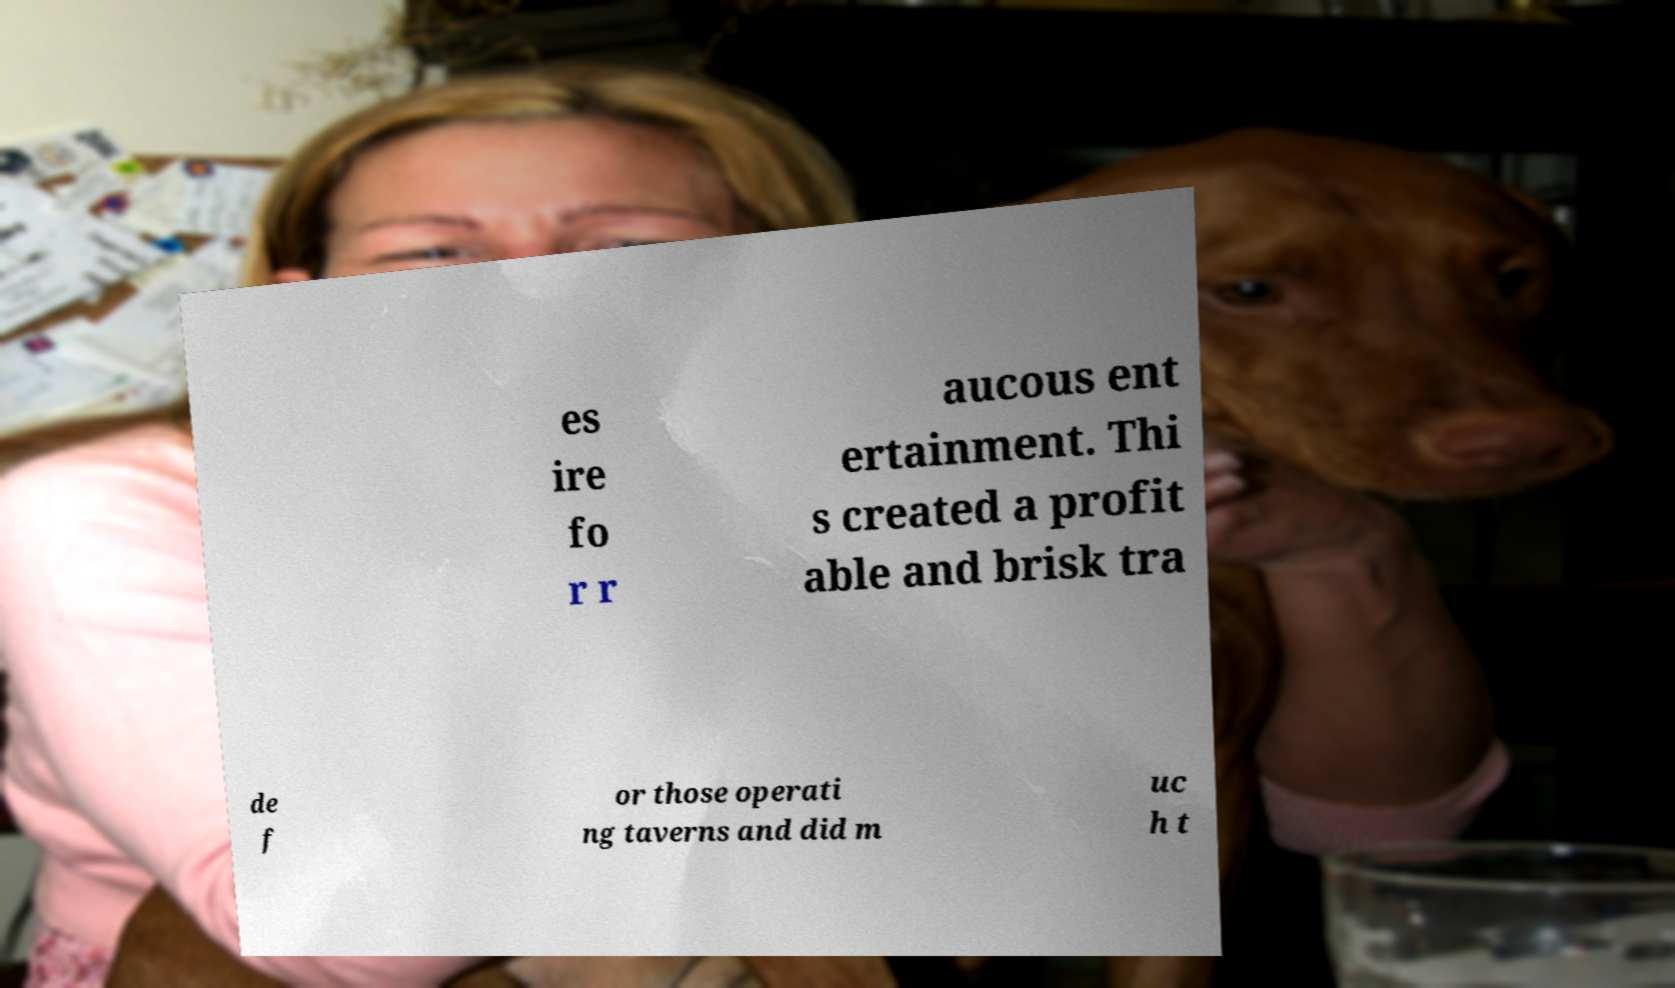Please identify and transcribe the text found in this image. es ire fo r r aucous ent ertainment. Thi s created a profit able and brisk tra de f or those operati ng taverns and did m uc h t 